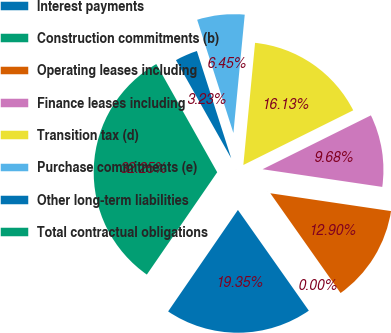Convert chart to OTSL. <chart><loc_0><loc_0><loc_500><loc_500><pie_chart><fcel>Interest payments<fcel>Construction commitments (b)<fcel>Operating leases including<fcel>Finance leases including<fcel>Transition tax (d)<fcel>Purchase commitments (e)<fcel>Other long-term liabilities<fcel>Total contractual obligations<nl><fcel>19.35%<fcel>0.0%<fcel>12.9%<fcel>9.68%<fcel>16.13%<fcel>6.45%<fcel>3.23%<fcel>32.25%<nl></chart> 